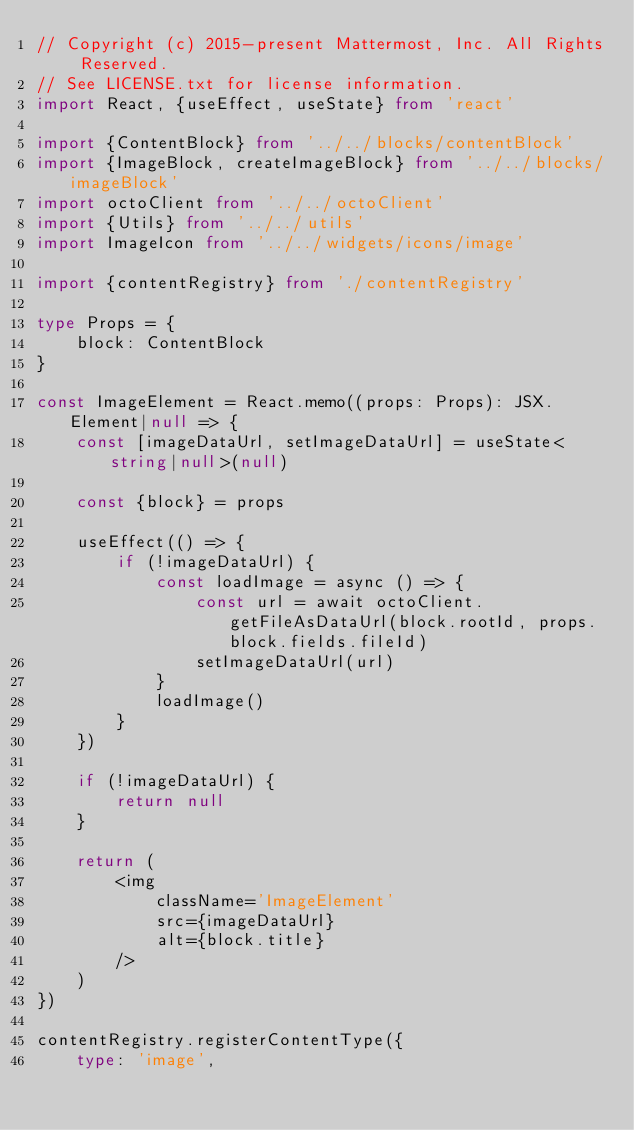Convert code to text. <code><loc_0><loc_0><loc_500><loc_500><_TypeScript_>// Copyright (c) 2015-present Mattermost, Inc. All Rights Reserved.
// See LICENSE.txt for license information.
import React, {useEffect, useState} from 'react'

import {ContentBlock} from '../../blocks/contentBlock'
import {ImageBlock, createImageBlock} from '../../blocks/imageBlock'
import octoClient from '../../octoClient'
import {Utils} from '../../utils'
import ImageIcon from '../../widgets/icons/image'

import {contentRegistry} from './contentRegistry'

type Props = {
    block: ContentBlock
}

const ImageElement = React.memo((props: Props): JSX.Element|null => {
    const [imageDataUrl, setImageDataUrl] = useState<string|null>(null)

    const {block} = props

    useEffect(() => {
        if (!imageDataUrl) {
            const loadImage = async () => {
                const url = await octoClient.getFileAsDataUrl(block.rootId, props.block.fields.fileId)
                setImageDataUrl(url)
            }
            loadImage()
        }
    })

    if (!imageDataUrl) {
        return null
    }

    return (
        <img
            className='ImageElement'
            src={imageDataUrl}
            alt={block.title}
        />
    )
})

contentRegistry.registerContentType({
    type: 'image',</code> 